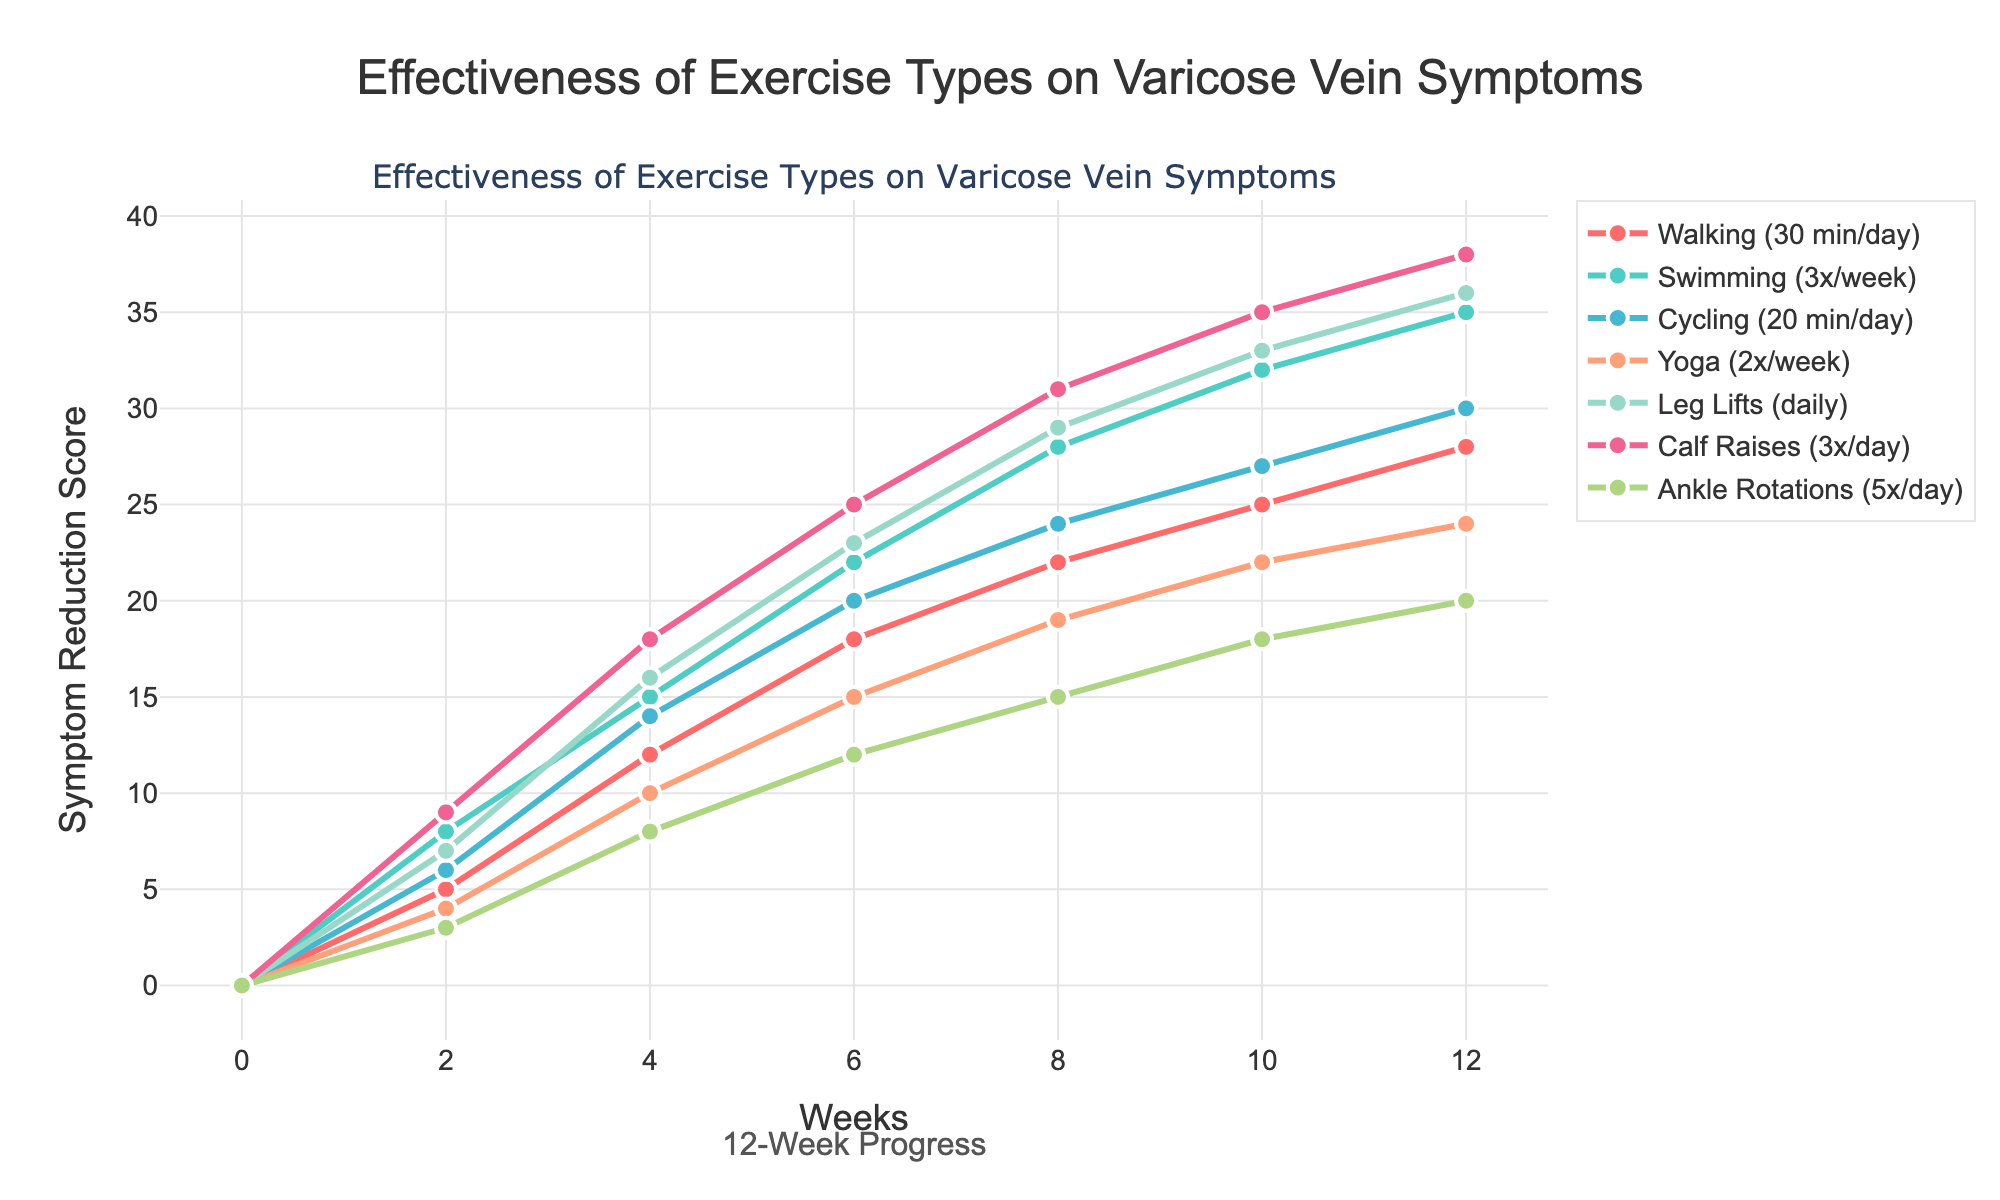Which exercise type shows the highest symptom reduction score at week 12? Look for the endpoint of the curves at week 12, then identify which one is the highest. The "Calf Raises (3x/day)" line ends at 38, which is the highest.
Answer: Calf Raises (3x/day) Which exercise type shows a consistent improvement every 2 weeks without any decrease? Check each exercise type's line for a steady upward trend without any drops at any point. All lines show consistent improvement.
Answer: All exercises By how much did "Walking (30 min/day)" improve from week 0 to week 12? Subtract the week 0 symptom reduction score from the week 12 score for "Walking". 28 (week 12) - 0 (week 0) = 28.
Answer: 28 Which exercise type had the smallest symptom reduction score at week 4? Check the y-values for each exercise type at week 4. "Ankle Rotations (5x/day)" has the smallest value of 8 at week 4.
Answer: Ankle Rotations (5x/day) Between "Yoga (2x/week)" and "Cycling (20 min/day)", which one had a greater improvement between week 8 and week 12? Compare the differences in scores between week 8 and week 12 for both exercises: Yoga (24 - 19 = 5) and Cycling (30 - 24 = 6). Cycling shows a greater improvement.
Answer: Cycling (20 min/day) What is the average symptom reduction score for "Leg Lifts (daily)" over the 12-week period? Sum the values for "Leg Lifts (daily)" across all weeks and divide by the number of weeks: (0 + 7 + 16 + 23 + 29 + 33 + 36) / 7 = 144 / 7 ≈ 20.57.
Answer: ~20.57 How much more effective was "Swimming (3x/week)" than "Walking (30 min/day)" at week 6? Subtract the symptom reduction score for "Walking" from that of "Swimming" at week 6. Swimming (22) - Walking (18) = 4.
Answer: 4 